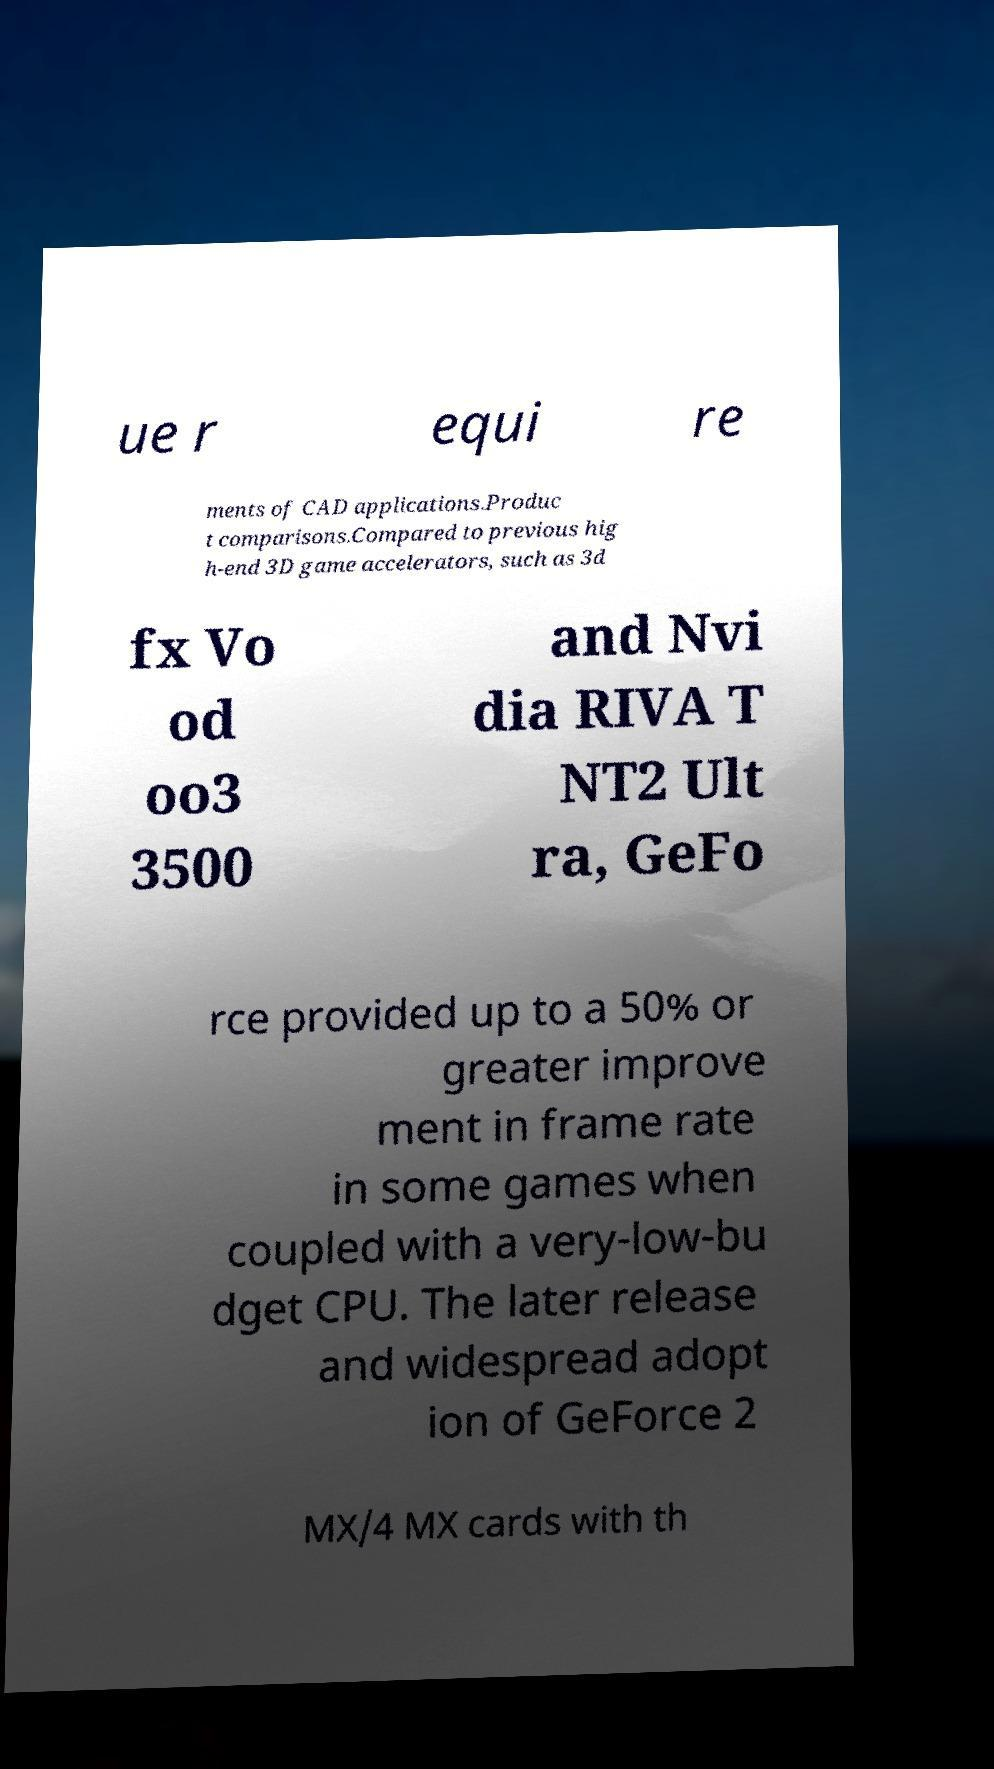I need the written content from this picture converted into text. Can you do that? ue r equi re ments of CAD applications.Produc t comparisons.Compared to previous hig h-end 3D game accelerators, such as 3d fx Vo od oo3 3500 and Nvi dia RIVA T NT2 Ult ra, GeFo rce provided up to a 50% or greater improve ment in frame rate in some games when coupled with a very-low-bu dget CPU. The later release and widespread adopt ion of GeForce 2 MX/4 MX cards with th 